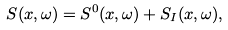Convert formula to latex. <formula><loc_0><loc_0><loc_500><loc_500>S ( x , \omega ) = S ^ { 0 } ( x , \omega ) + S _ { I } ( x , \omega ) ,</formula> 